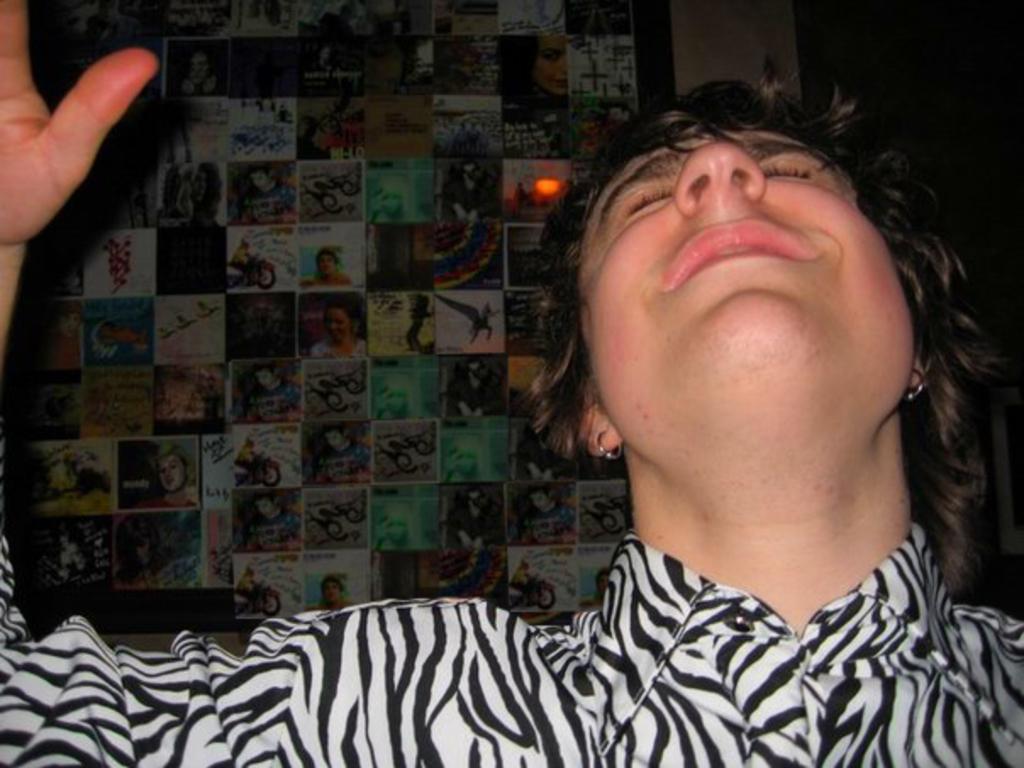Could you give a brief overview of what you see in this image? In this picture there is a lady on the right side of the image and there is a poster in the background area of the image, it seems to be she is crying. 